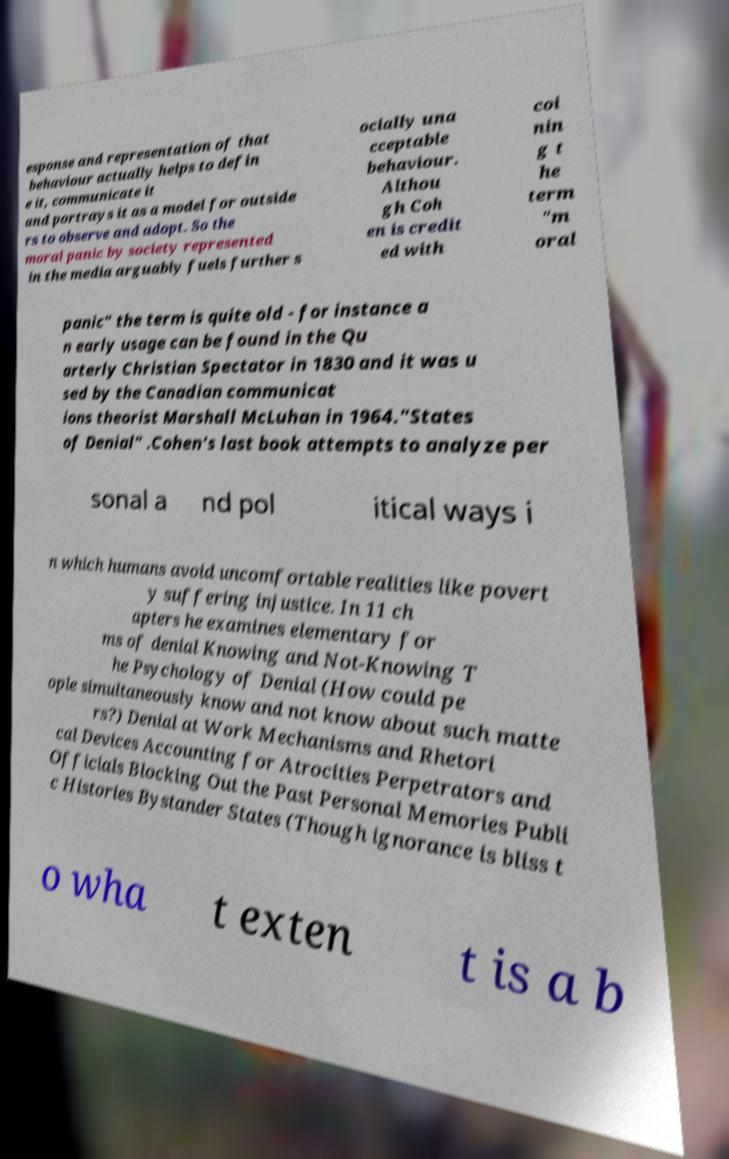Can you accurately transcribe the text from the provided image for me? esponse and representation of that behaviour actually helps to defin e it, communicate it and portrays it as a model for outside rs to observe and adopt. So the moral panic by society represented in the media arguably fuels further s ocially una cceptable behaviour. Althou gh Coh en is credit ed with coi nin g t he term "m oral panic" the term is quite old - for instance a n early usage can be found in the Qu arterly Christian Spectator in 1830 and it was u sed by the Canadian communicat ions theorist Marshall McLuhan in 1964."States of Denial" .Cohen's last book attempts to analyze per sonal a nd pol itical ways i n which humans avoid uncomfortable realities like povert y suffering injustice. In 11 ch apters he examines elementary for ms of denial Knowing and Not-Knowing T he Psychology of Denial (How could pe ople simultaneously know and not know about such matte rs?) Denial at Work Mechanisms and Rhetori cal Devices Accounting for Atrocities Perpetrators and Officials Blocking Out the Past Personal Memories Publi c Histories Bystander States (Though ignorance is bliss t o wha t exten t is a b 